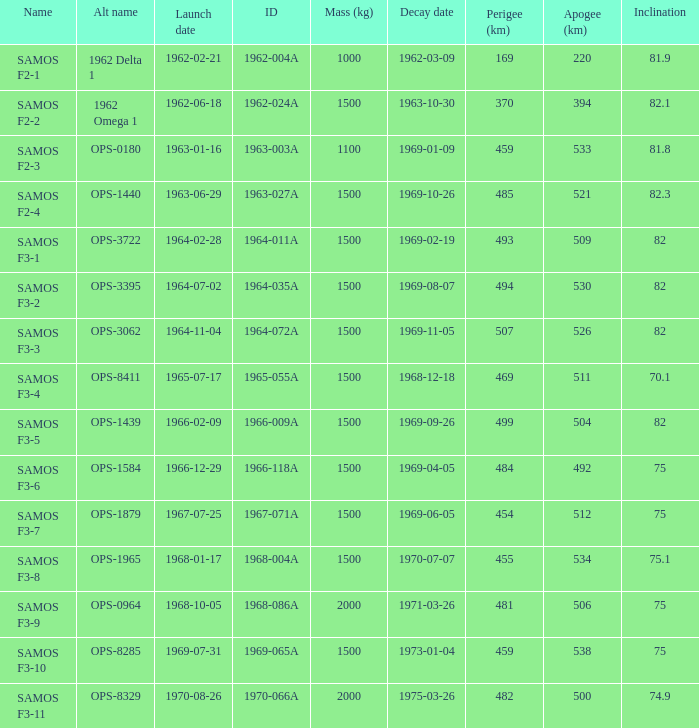What was the peak perigee reached on the 9th of january, 1969? 459.0. 